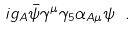<formula> <loc_0><loc_0><loc_500><loc_500>i g _ { A } \bar { \psi } \gamma ^ { \mu } \gamma _ { 5 } \alpha _ { A \mu } \psi \ .</formula> 